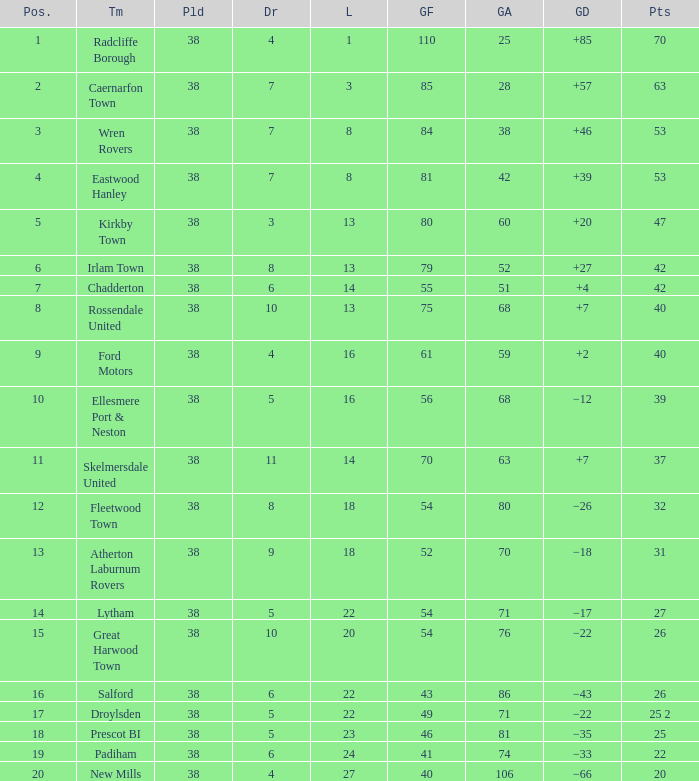How much Drawn has Goals Against of 81, and a Lost larger than 23? 0.0. 